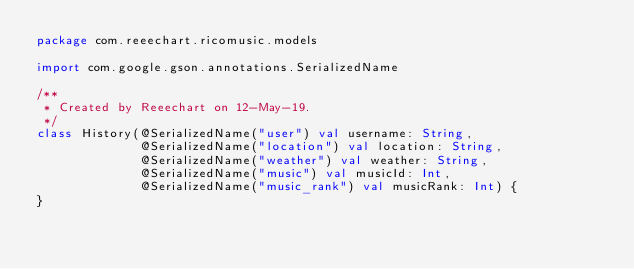Convert code to text. <code><loc_0><loc_0><loc_500><loc_500><_Kotlin_>package com.reeechart.ricomusic.models

import com.google.gson.annotations.SerializedName

/**
 * Created by Reeechart on 12-May-19.
 */
class History(@SerializedName("user") val username: String,
              @SerializedName("location") val location: String,
              @SerializedName("weather") val weather: String,
              @SerializedName("music") val musicId: Int,
              @SerializedName("music_rank") val musicRank: Int) {
}</code> 